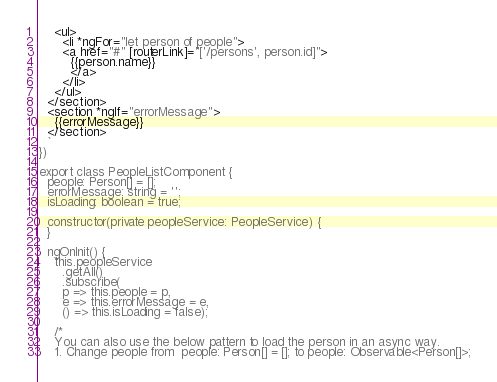Convert code to text. <code><loc_0><loc_0><loc_500><loc_500><_TypeScript_>    <ul>
      <li *ngFor="let person of people">
      <a href="#" [routerLink]="['/persons', person.id]">
        {{person.name}}
        </a>
      </li>
    </ul>
  </section>
  <section *ngIf="errorMessage">
    {{errorMessage}}
  </section>
  `
})

export class PeopleListComponent {
  people: Person[] = [];
  errorMessage: string = '';
  isLoading: boolean = true;

  constructor(private peopleService: PeopleService) {
  }

  ngOnInit() {
    this.peopleService
      .getAll()
      .subscribe(
      p => this.people = p,
      e => this.errorMessage = e,
      () => this.isLoading = false);

    /*
    You can also use the below pattern to load the person in an async way.
    1. Change people from  people: Person[] = []; to people: Observable<Person[]>;</code> 